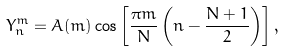Convert formula to latex. <formula><loc_0><loc_0><loc_500><loc_500>Y ^ { m } _ { n } = A ( m ) \cos \left [ \frac { \pi m } { N } \left ( n - \frac { N + 1 } { 2 } \right ) \right ] ,</formula> 